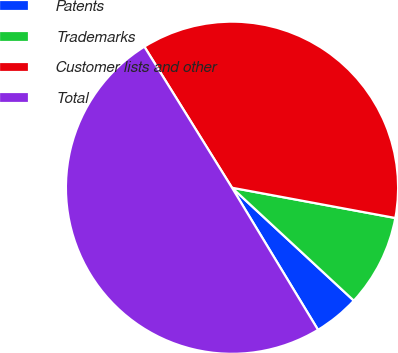Convert chart to OTSL. <chart><loc_0><loc_0><loc_500><loc_500><pie_chart><fcel>Patents<fcel>Trademarks<fcel>Customer lists and other<fcel>Total<nl><fcel>4.44%<fcel>8.98%<fcel>36.76%<fcel>49.81%<nl></chart> 